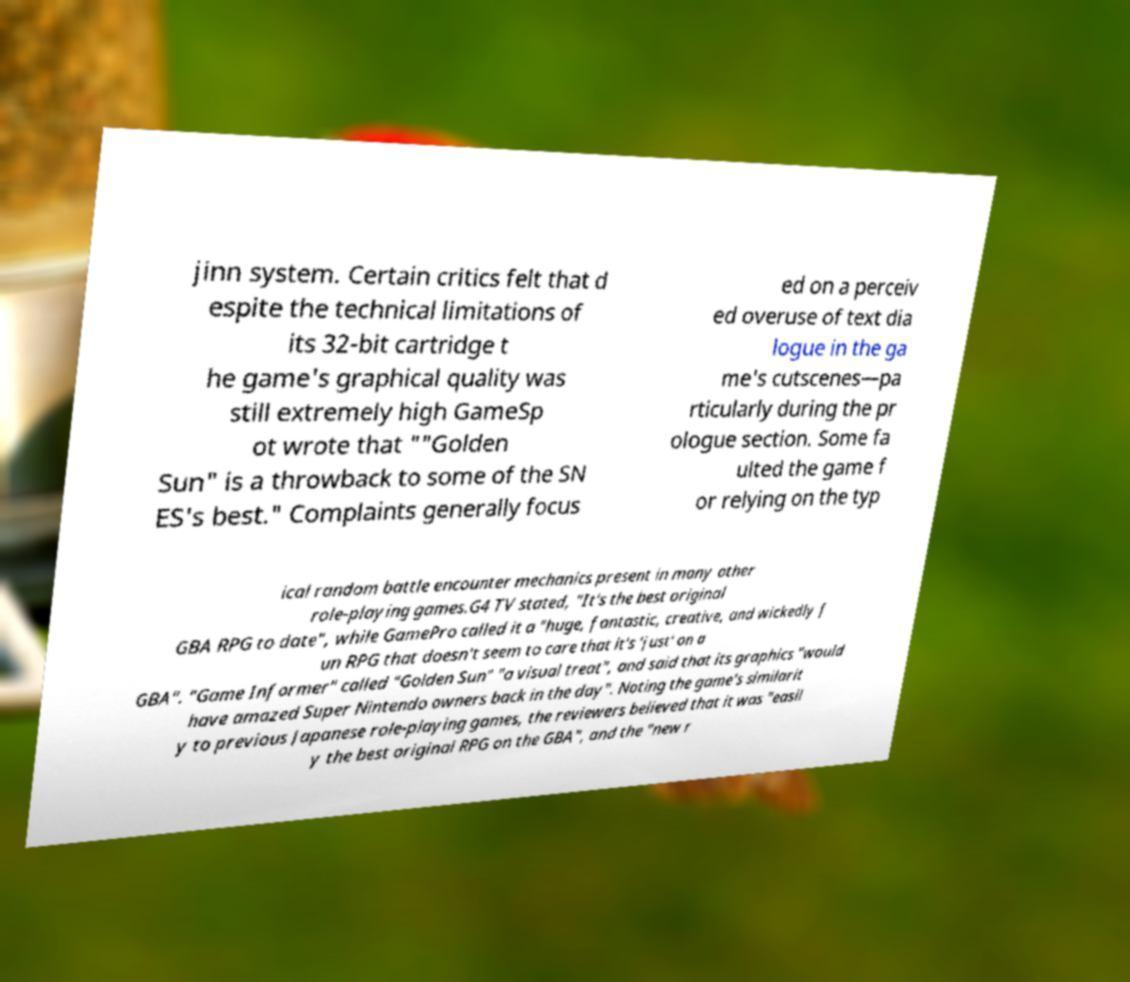Please read and relay the text visible in this image. What does it say? jinn system. Certain critics felt that d espite the technical limitations of its 32-bit cartridge t he game's graphical quality was still extremely high GameSp ot wrote that ""Golden Sun" is a throwback to some of the SN ES's best." Complaints generally focus ed on a perceiv ed overuse of text dia logue in the ga me's cutscenes—pa rticularly during the pr ologue section. Some fa ulted the game f or relying on the typ ical random battle encounter mechanics present in many other role-playing games.G4 TV stated, "It's the best original GBA RPG to date", while GamePro called it a "huge, fantastic, creative, and wickedly f un RPG that doesn't seem to care that it's 'just' on a GBA". "Game Informer" called "Golden Sun" "a visual treat", and said that its graphics "would have amazed Super Nintendo owners back in the day". Noting the game's similarit y to previous Japanese role-playing games, the reviewers believed that it was "easil y the best original RPG on the GBA", and the "new r 